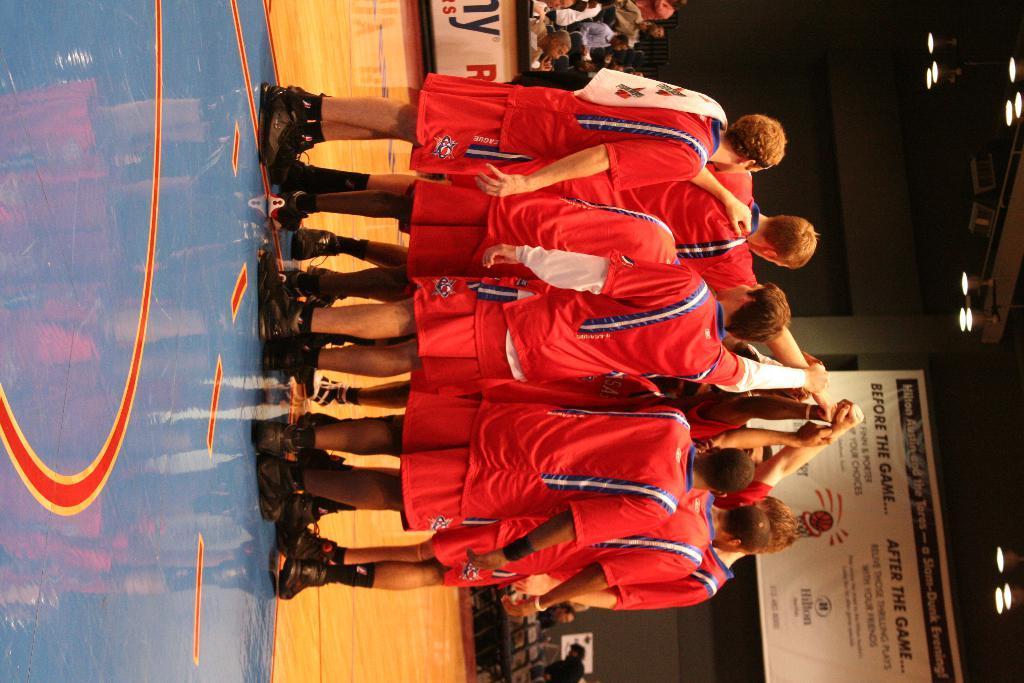Can you describe this image briefly? In the middle of this image, there are players in red color dresses, standing on the court. In the background, there is a banner, there are persons, there are lights attached to the roof and there are other objects. 